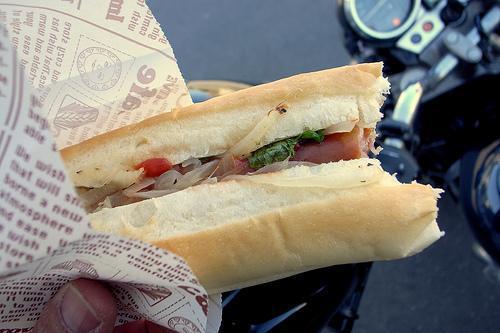How many sandwiches are in the picture?
Give a very brief answer. 1. 